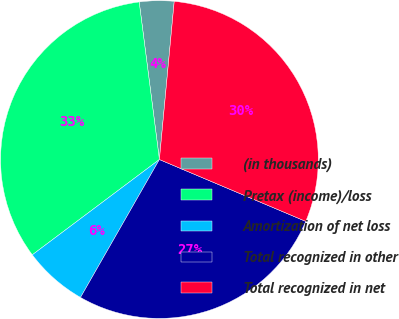<chart> <loc_0><loc_0><loc_500><loc_500><pie_chart><fcel>(in thousands)<fcel>Pretax (income)/loss<fcel>Amortization of net loss<fcel>Total recognized in other<fcel>Total recognized in net<nl><fcel>3.52%<fcel>33.21%<fcel>6.49%<fcel>26.91%<fcel>29.88%<nl></chart> 